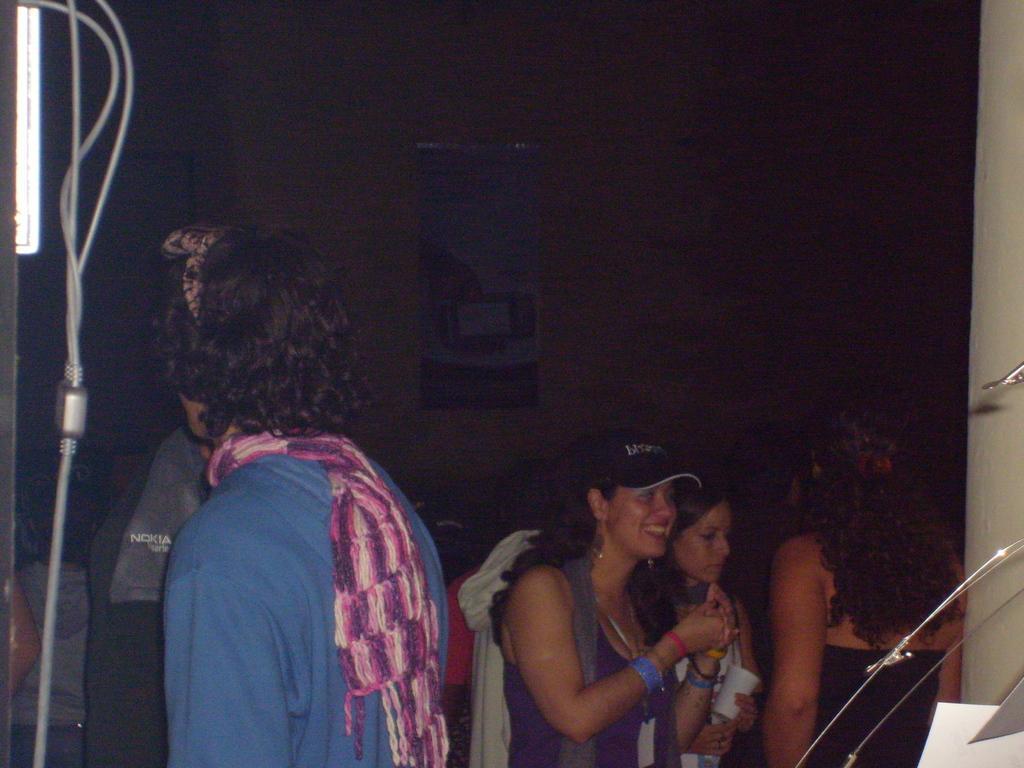In one or two sentences, can you explain what this image depicts? In the center of the image there are people standing. In the background of the image there is wall. 